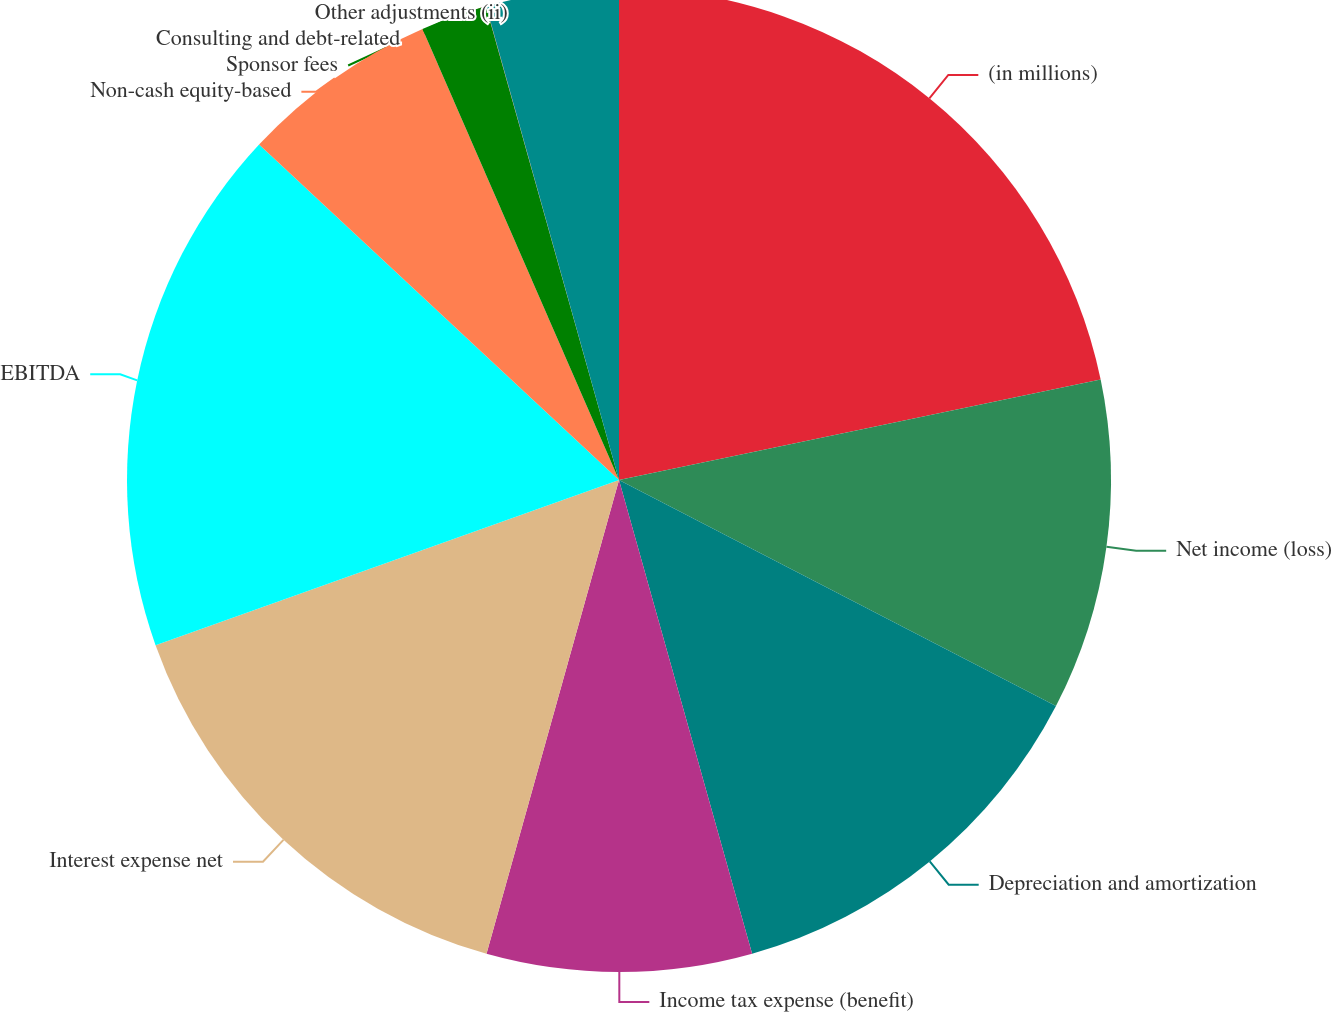<chart> <loc_0><loc_0><loc_500><loc_500><pie_chart><fcel>(in millions)<fcel>Net income (loss)<fcel>Depreciation and amortization<fcel>Income tax expense (benefit)<fcel>Interest expense net<fcel>EBITDA<fcel>Non-cash equity-based<fcel>Sponsor fees<fcel>Consulting and debt-related<fcel>Other adjustments (ii)<nl><fcel>21.73%<fcel>10.87%<fcel>13.04%<fcel>8.7%<fcel>15.21%<fcel>17.39%<fcel>6.52%<fcel>2.18%<fcel>0.01%<fcel>4.35%<nl></chart> 